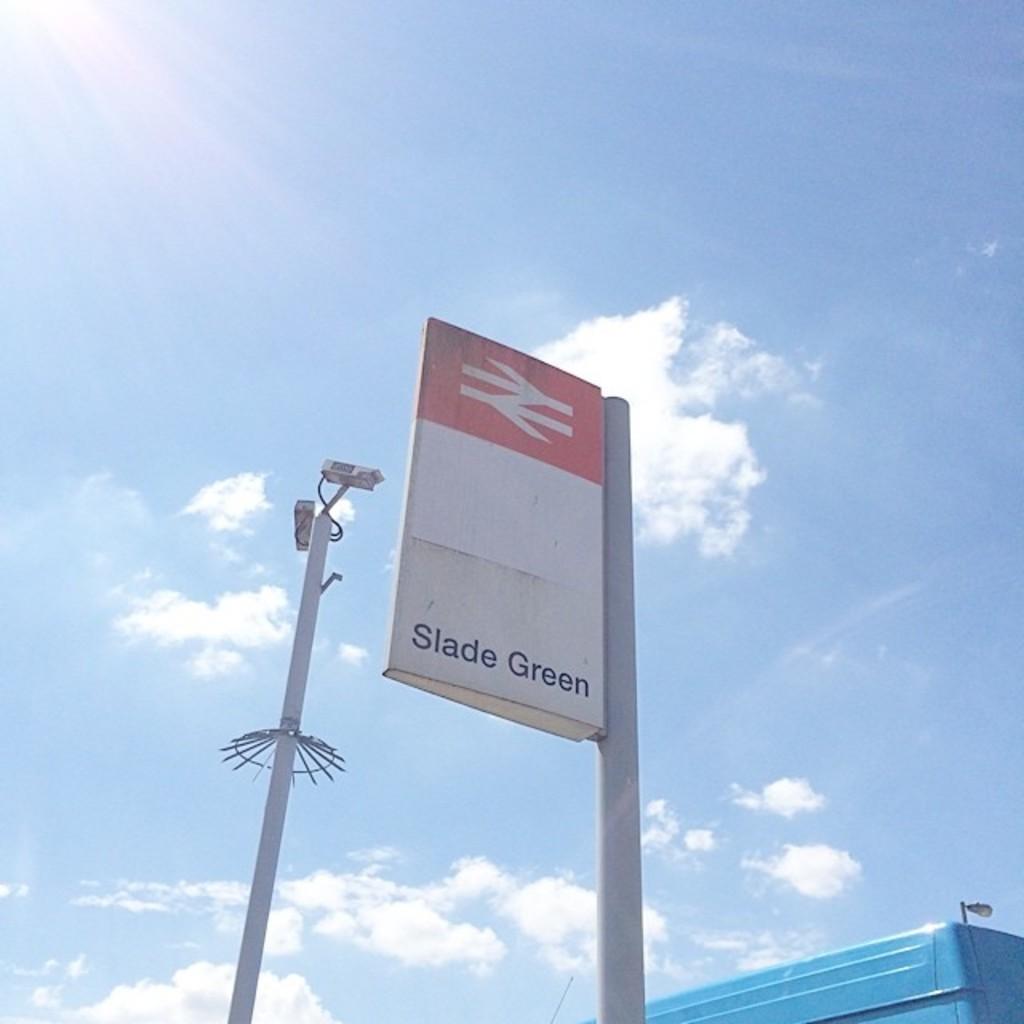What is the name of the section?
Offer a terse response. Slade green. 